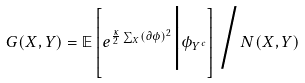<formula> <loc_0><loc_0><loc_500><loc_500>G ( X , Y ) = \mathbb { E } \left [ e ^ { \frac { \kappa } { 2 } \sum _ { X } ( \partial \phi ) ^ { 2 } } \Big | \phi _ { Y ^ { c } } \right ] \Big / N ( X , Y )</formula> 